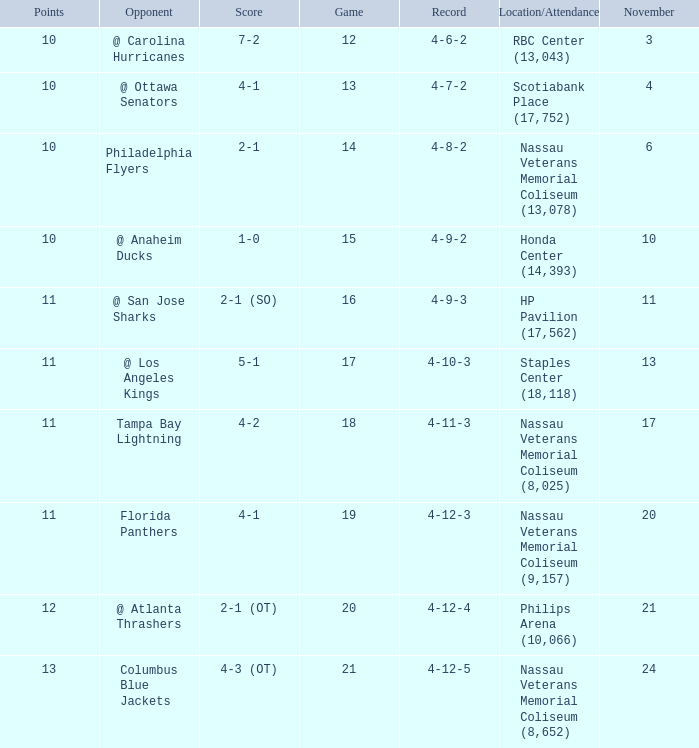What is the least entry for game if the score is 1-0? 15.0. 